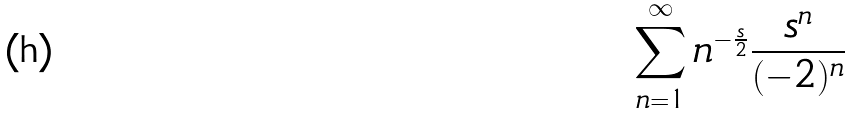<formula> <loc_0><loc_0><loc_500><loc_500>\sum _ { n = 1 } ^ { \infty } n ^ { - \frac { s } { 2 } } \frac { s ^ { n } } { ( - 2 ) ^ { n } }</formula> 